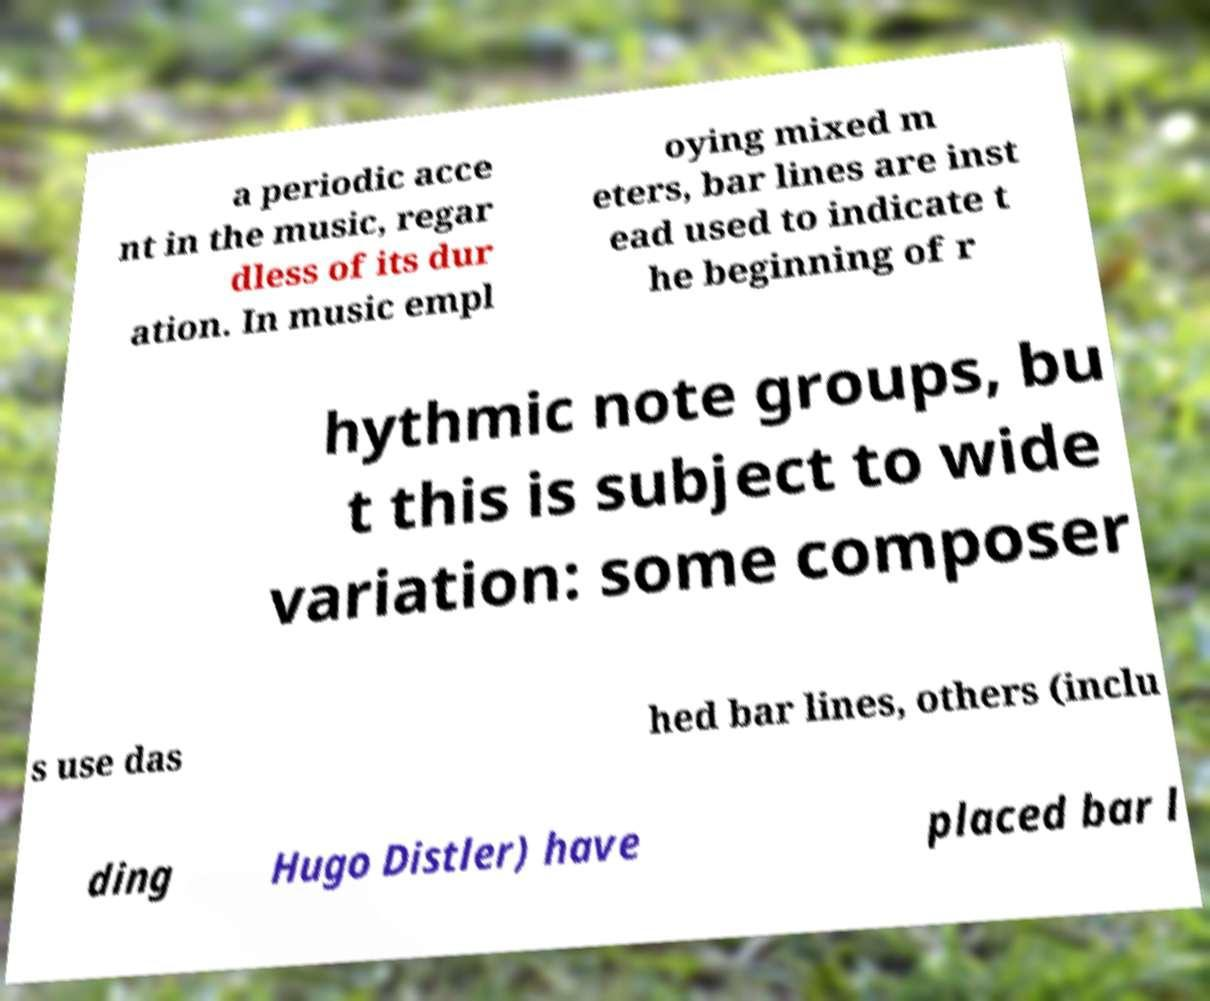Could you assist in decoding the text presented in this image and type it out clearly? a periodic acce nt in the music, regar dless of its dur ation. In music empl oying mixed m eters, bar lines are inst ead used to indicate t he beginning of r hythmic note groups, bu t this is subject to wide variation: some composer s use das hed bar lines, others (inclu ding Hugo Distler) have placed bar l 